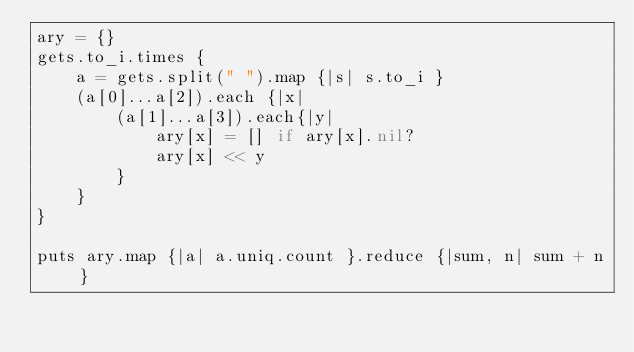Convert code to text. <code><loc_0><loc_0><loc_500><loc_500><_Ruby_>ary = {}
gets.to_i.times {
    a = gets.split(" ").map {|s| s.to_i }
    (a[0]...a[2]).each {|x|
        (a[1]...a[3]).each{|y|
            ary[x] = [] if ary[x].nil?
            ary[x] << y
        }
    }
}

puts ary.map {|a| a.uniq.count }.reduce {|sum, n| sum + n }</code> 